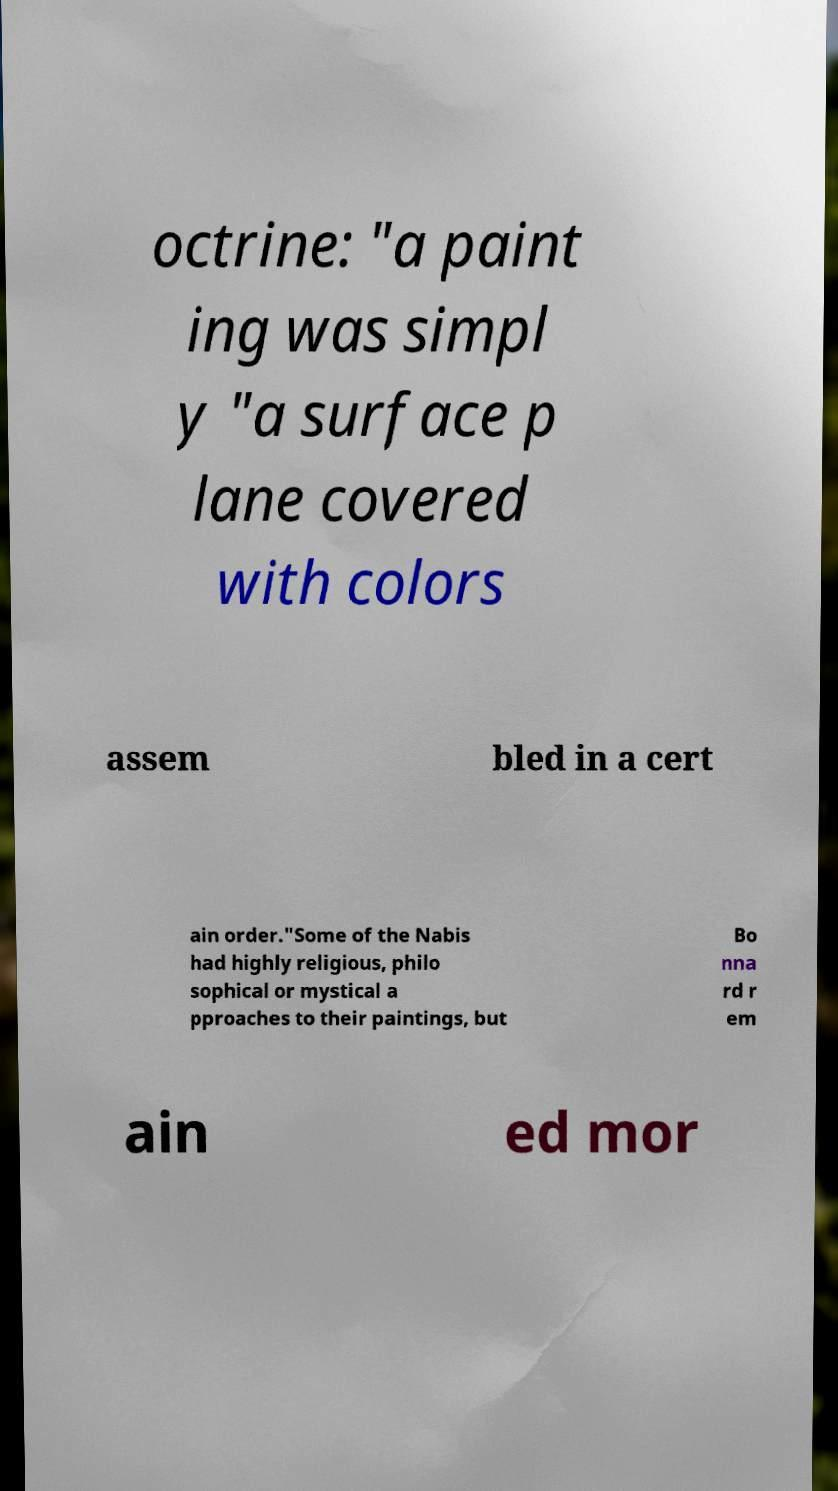I need the written content from this picture converted into text. Can you do that? octrine: "a paint ing was simpl y "a surface p lane covered with colors assem bled in a cert ain order."Some of the Nabis had highly religious, philo sophical or mystical a pproaches to their paintings, but Bo nna rd r em ain ed mor 